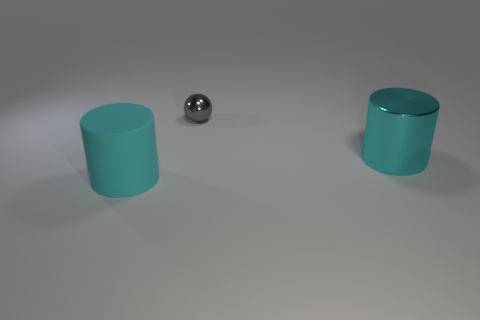Is there anything else that has the same size as the gray metallic object?
Give a very brief answer. No. Is there anything else that has the same shape as the tiny shiny object?
Your answer should be compact. No. There is a large cyan thing right of the cyan rubber cylinder; does it have the same shape as the cyan thing on the left side of the tiny ball?
Give a very brief answer. Yes. Is there a large red ball that has the same material as the small sphere?
Provide a short and direct response. No. How many cyan things are cylinders or big matte spheres?
Ensure brevity in your answer.  2. What size is the thing that is on the left side of the cyan shiny cylinder and to the right of the big matte cylinder?
Provide a short and direct response. Small. Is the number of small gray balls left of the large metallic object greater than the number of small cyan shiny cubes?
Your response must be concise. Yes. How many spheres are gray objects or cyan rubber objects?
Your answer should be compact. 1. What shape is the object that is both in front of the gray object and to the left of the large metallic cylinder?
Your answer should be compact. Cylinder. Are there an equal number of cyan rubber things that are behind the big shiny object and cyan objects that are to the left of the gray ball?
Ensure brevity in your answer.  No. 